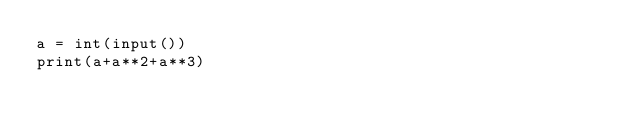<code> <loc_0><loc_0><loc_500><loc_500><_Python_>a = int(input())
print(a+a**2+a**3)</code> 